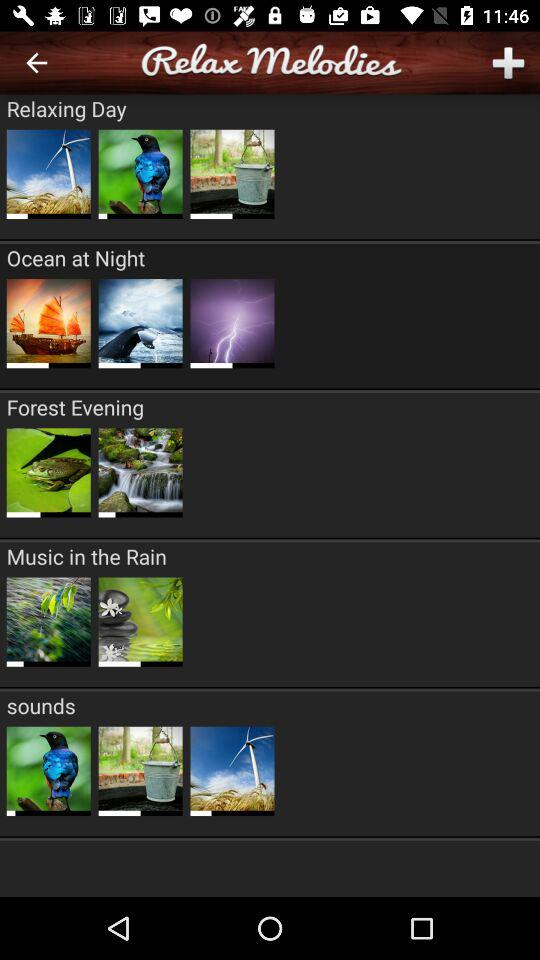What is the name of the application?
When the provided information is insufficient, respond with <no answer>. <no answer> 